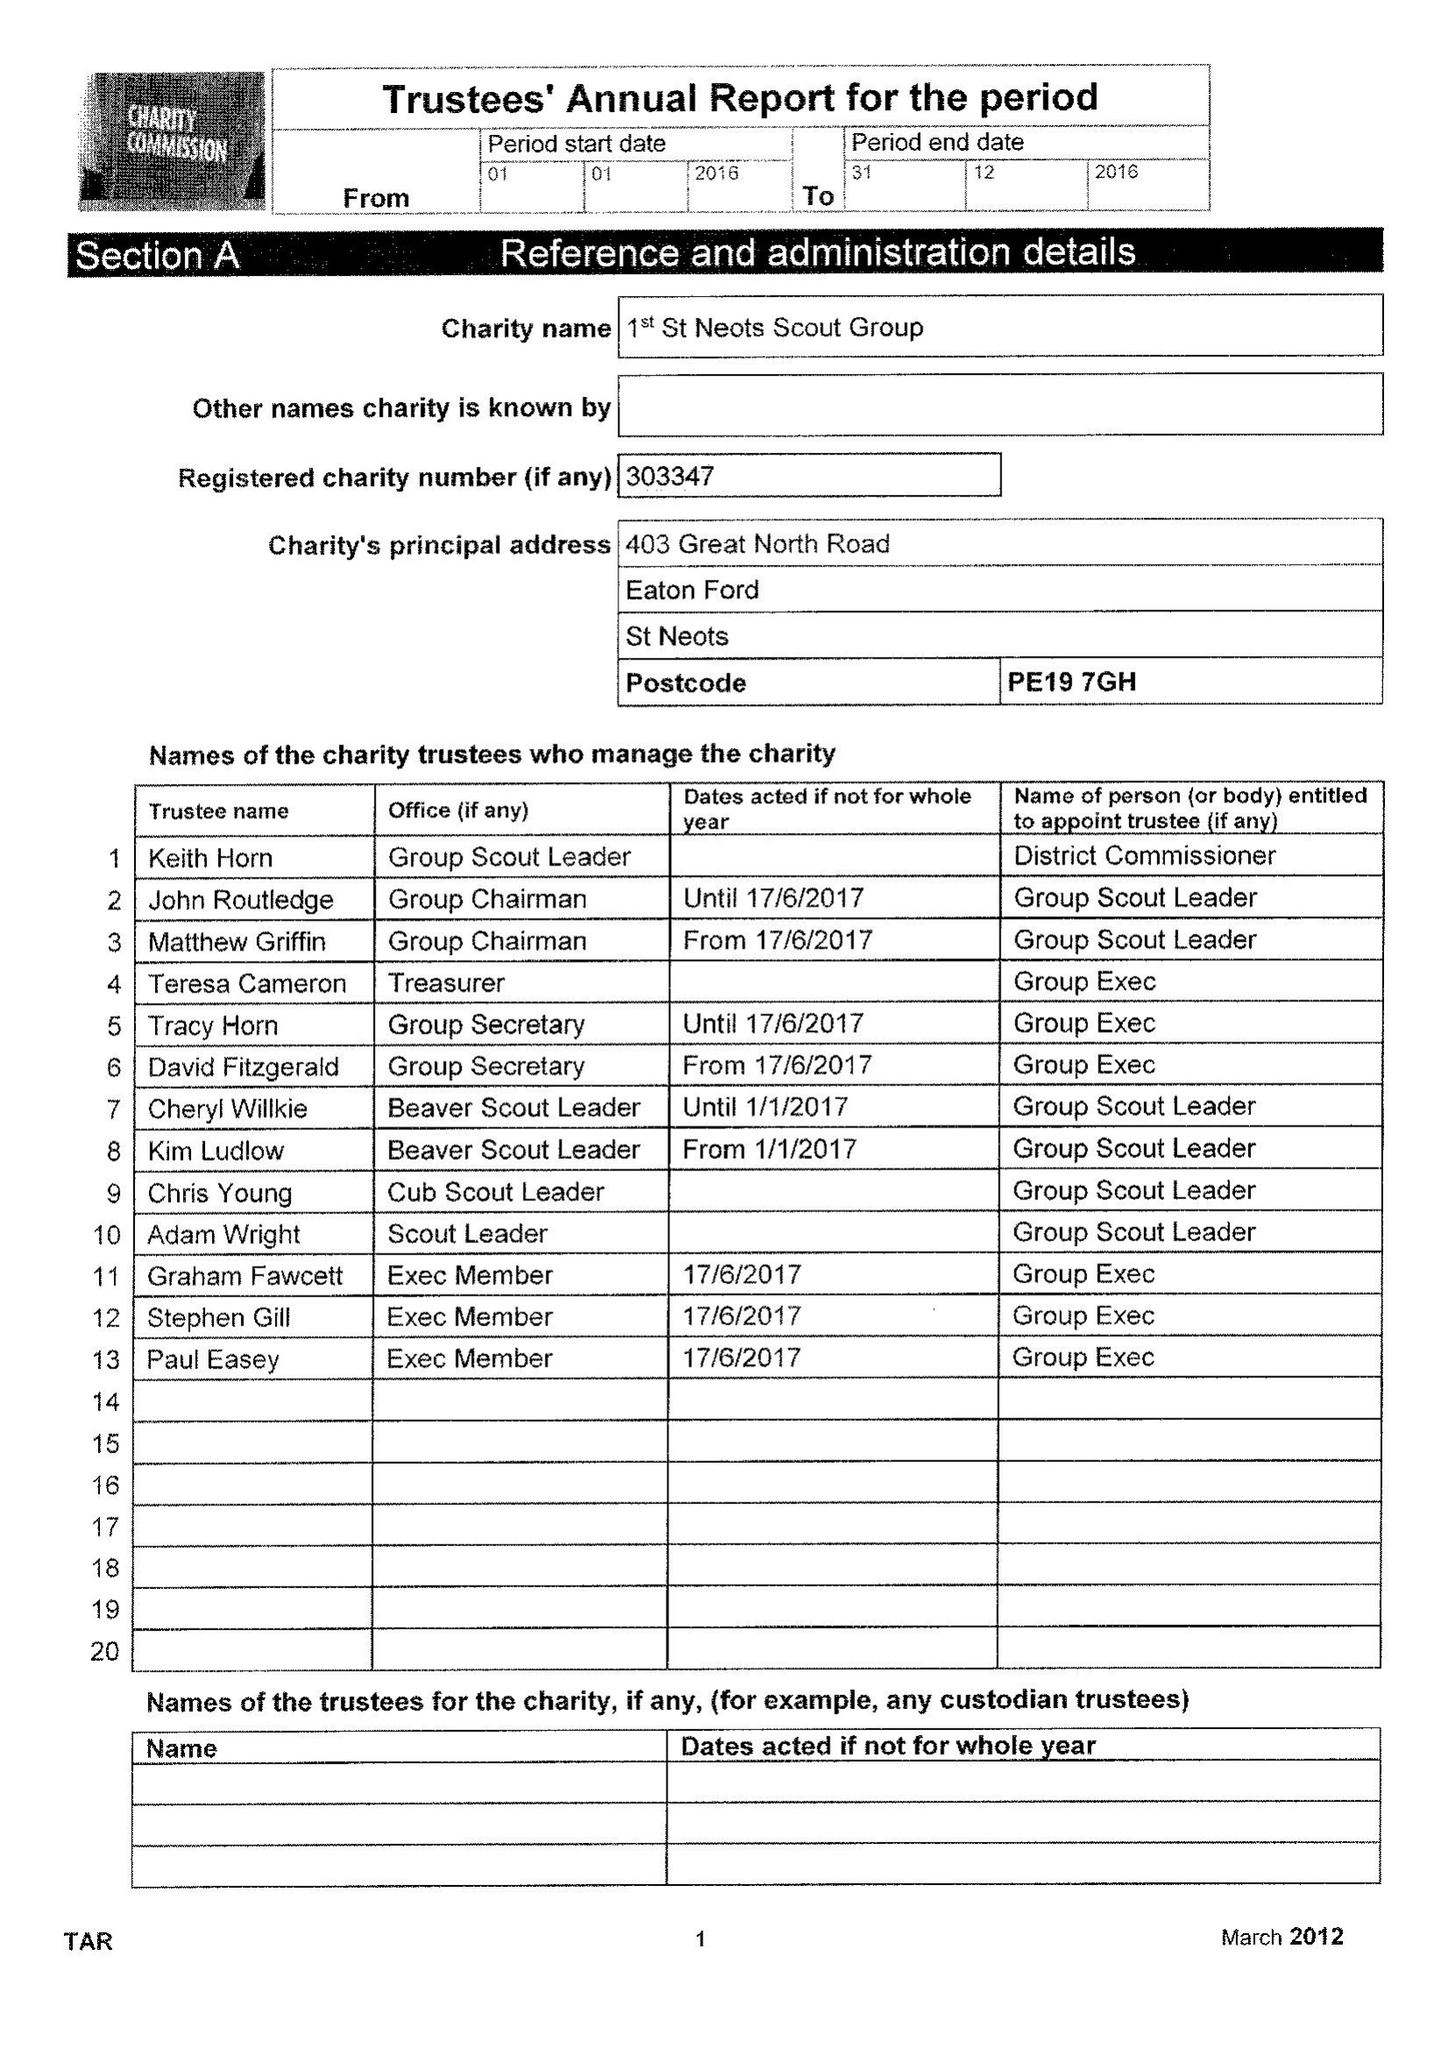What is the value for the income_annually_in_british_pounds?
Answer the question using a single word or phrase. 79121.00 